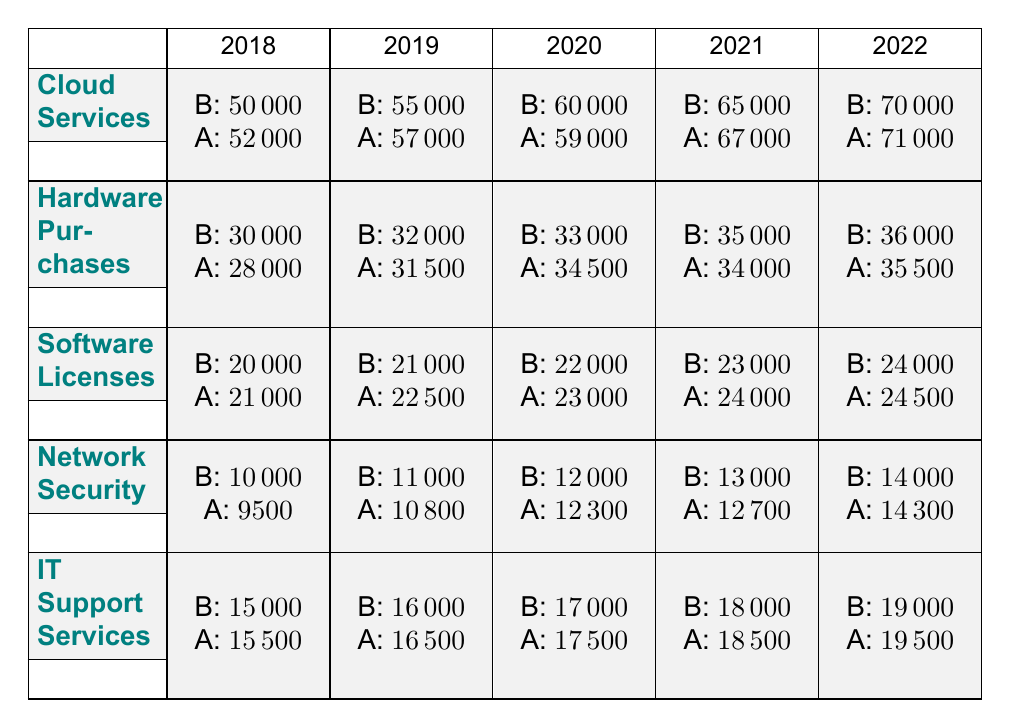What was the actual spending on Cloud Services in 2019? In 2019, the table shows that the actual spending on Cloud Services was 57000.
Answer: 57000 What was the budget for Hardware Purchases in 2021? The table indicates that the budget for Hardware Purchases in 2021 was 35000.
Answer: 35000 Did the IT Support Services actual spending exceed the budget in 2020? In 2020, the actual spending on IT Support Services was 17500, while the budget was 17000. Since 17500 is greater than 17000, the actual spending exceeded the budget.
Answer: Yes Which category had the largest budget in 2022? The category with the largest budget in 2022 was Cloud Services, with a budget of 70000.
Answer: Cloud Services What is the total actual spending on Software Licenses from 2018 to 2022? The actual spending on Software Licenses over the years is as follows: 21000 (2018) + 22500 (2019) + 23000 (2020) + 24000 (2021) + 24500 (2022). The total is 21000 + 22500 + 23000 + 24000 + 24500 = 115000.
Answer: 115000 Was the average budget for Network Security over the years higher than 12000? The budgets for Network Security from 2018 to 2022 are: 10000, 11000, 12000, 13000, and 14000. The average budget is (10000 + 11000 + 12000 + 13000 + 14000) / 5 = 12000. Since the average is equal to 12000, it is not higher.
Answer: No What was the difference between the actual spending and budget for Cloud Services in 2020? The budget for Cloud Services in 2020 was 60000 and the actual spending was 59000. The difference is 60000 - 59000 = 1000.
Answer: 1000 Which year saw the highest over-expenditure in IT Support Services compared to its budget? To find the highest over-expenditure in IT Support Services, we look at each year: In 2018, 15500 - 15000 = 500; In 2019, 16500 - 16000 = 500; In 2020, 17500 - 17000 = 500; In 2021, 18500 - 18000 = 500; In 2022, 19500 - 19000 = 500. All years had an over-expenditure of 500. Therefore, there is no single year that had the highest over-expenditure, they are all equal.
Answer: No single year; all equal What was the trend of actual spending on Hardware Purchases from 2018 to 2022? The actual spending for Hardware Purchases from 2018 to 2022 was: 28000 (2018), 31500 (2019), 34500 (2020), 34000 (2021), and 35500 (2022). The spending increased from 2018 to 2020 but decreased slightly in 2021 before increasing again in 2022. Hence, the overall trend shows fluctuation with a slight increase at the end.
Answer: Fluctuating trend with a slight increase 